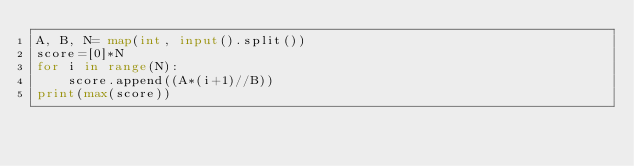Convert code to text. <code><loc_0><loc_0><loc_500><loc_500><_Python_>A, B, N= map(int, input().split())
score=[0]*N
for i in range(N):
    score.append((A*(i+1)//B))
print(max(score))</code> 